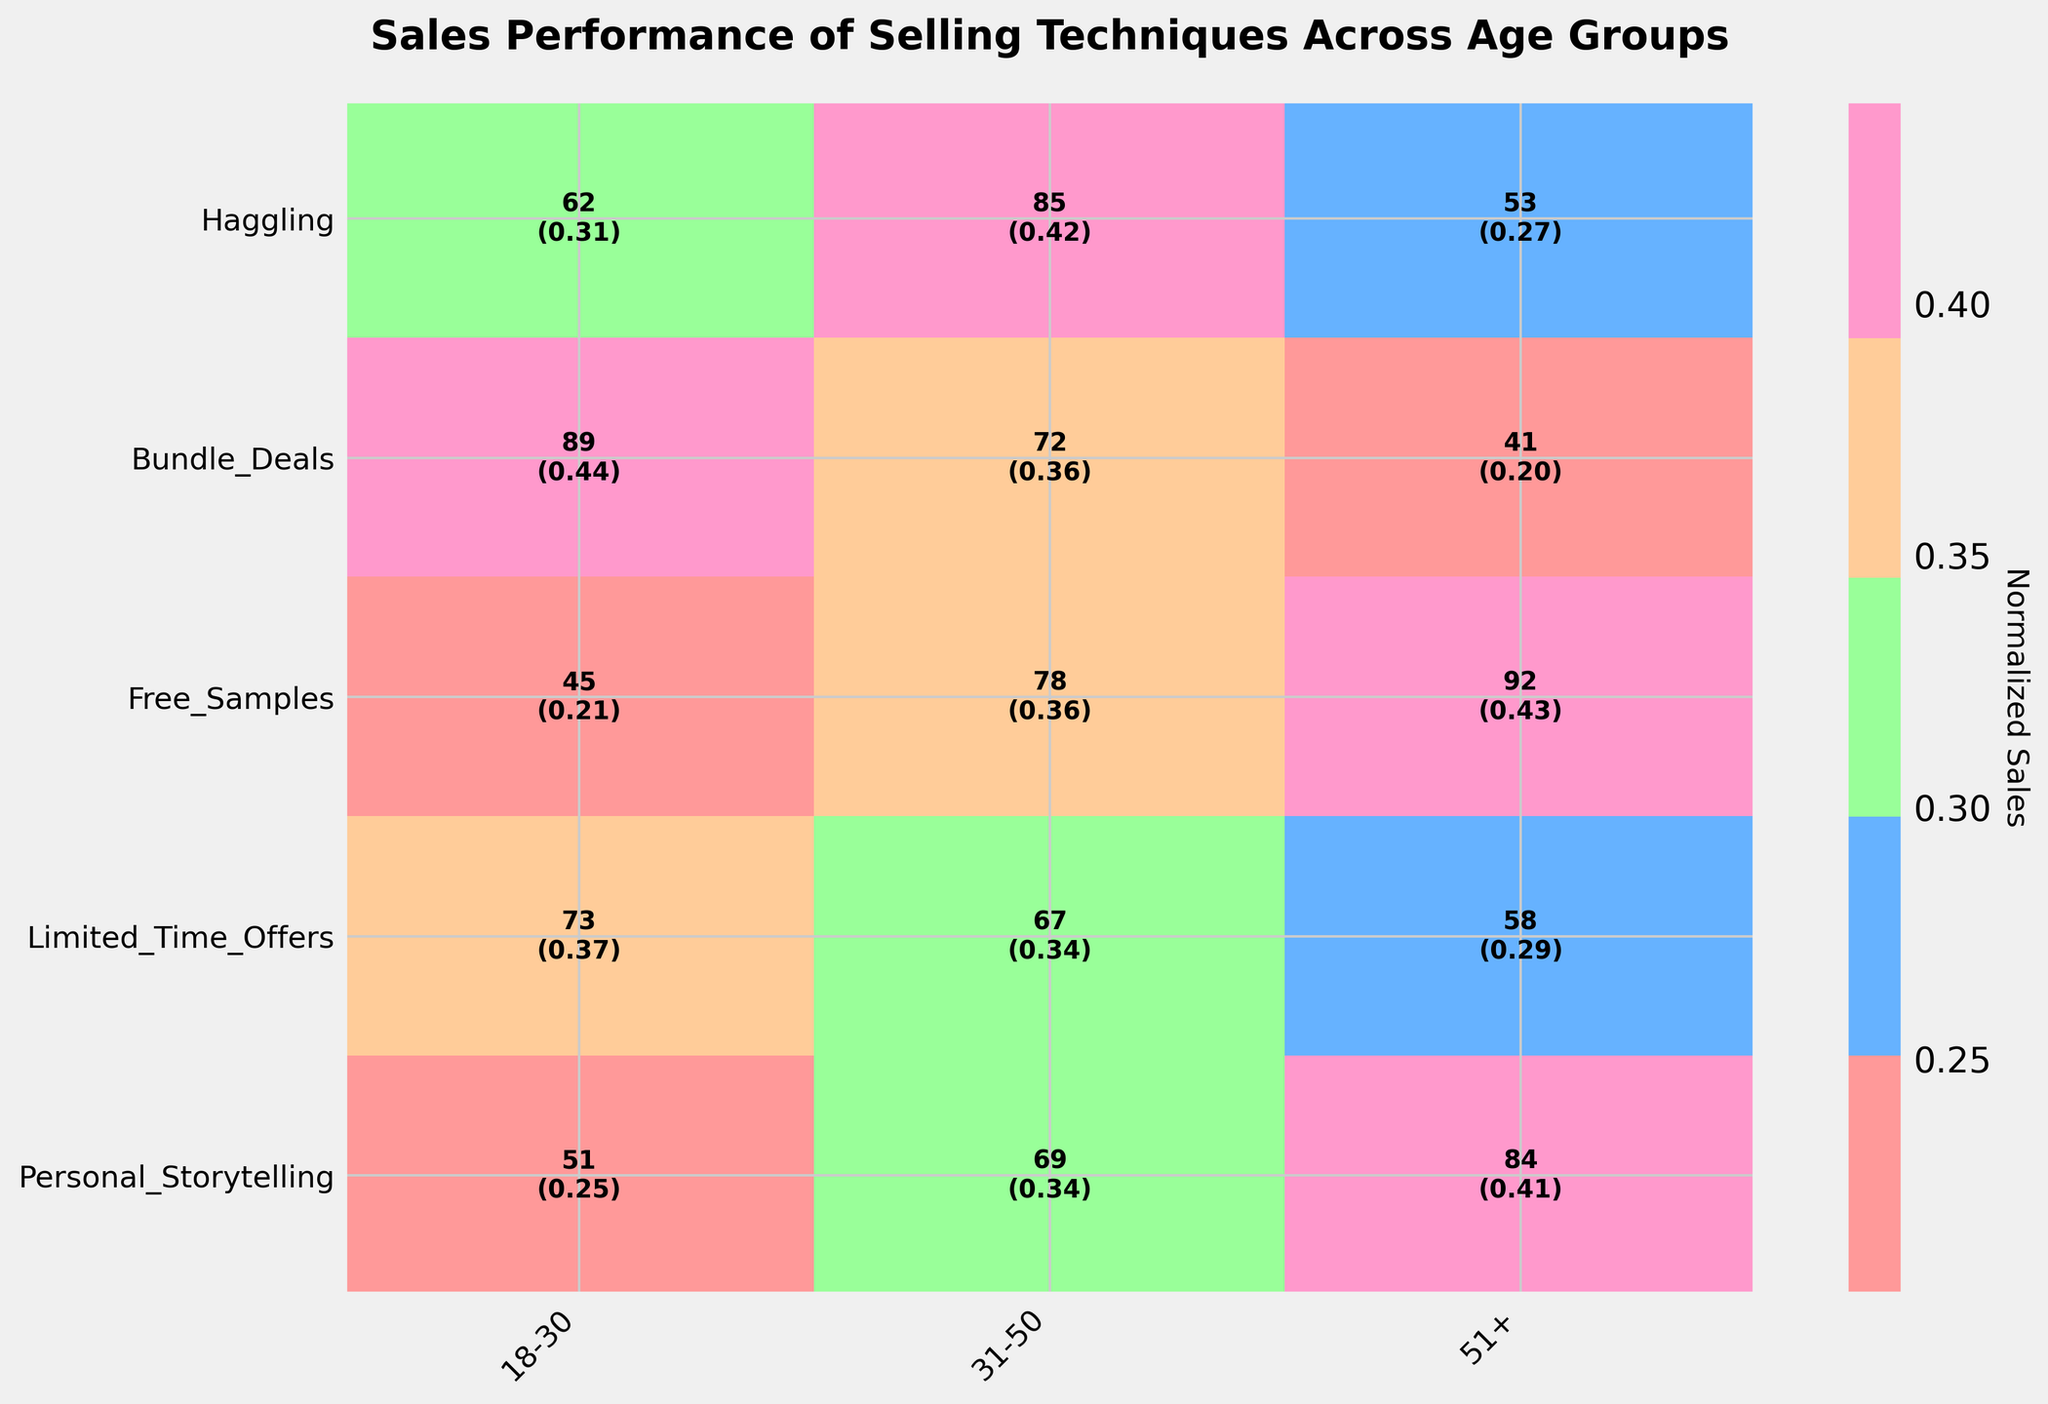What is the title of the plot? The title is usually displayed at the top of the plot. Reading it provides insight into what the plot represents.
Answer: Sales Performance of Selling Techniques Across Age Groups Which selling technique shows the highest normalized sales in the 18-30 age group? Look for the highest value in the 18-30 column and the corresponding selling technique.
Answer: Free Samples How many sales did Haggling achieve in the 31-50 age group? Locate the cell at the intersection of Haggling row and 31-50 column and note the sales count.
Answer: 78 What is the overall trend of Free Samples across different age groups? Observe the Free Samples row across different age groups and note whether the values increase or decrease.
Answer: Decreasing How do the normalized sales of Bundle Deals differ between the 18-30 and 51+ age groups? Compare the normalized values of Bundle Deals between the 18-30 and 51+ age groups.
Answer: 0.42 (18-30) vs. 0.26 (51+) Which age group shows the highest total sales across all selling techniques? Add up the sales counts for each age group and compare to determine the highest.
Answer: 31-50 Compare the effectiveness of Personal Storytelling and Haggling techniques for the 51+ age group. Look at the sales counts and normalized sales for both techniques in the 51+ age group and compare.
Answer: Personal Storytelling: 84 sales, 0.37 normalized; Haggling: 92 sales, 0.41 normalized What does the colorbar in the mosaic plot represent? Refer to the label and description of the colorbar usually positioned next to the plot.
Answer: Normalized Sales Which selling technique has the most consistent performance across age groups? Evaluate all techniques and identify which one has the least variation in normalized sales across age groups.
Answer: Limited Time Offers How do the sales of Limited Time Offers for the 31-50 age group compare to those of Free Samples for the same group? Find the sales counts for both techniques in the 31-50 age group and compare.
Answer: Limited Time Offers: 67; Free Samples: 72 